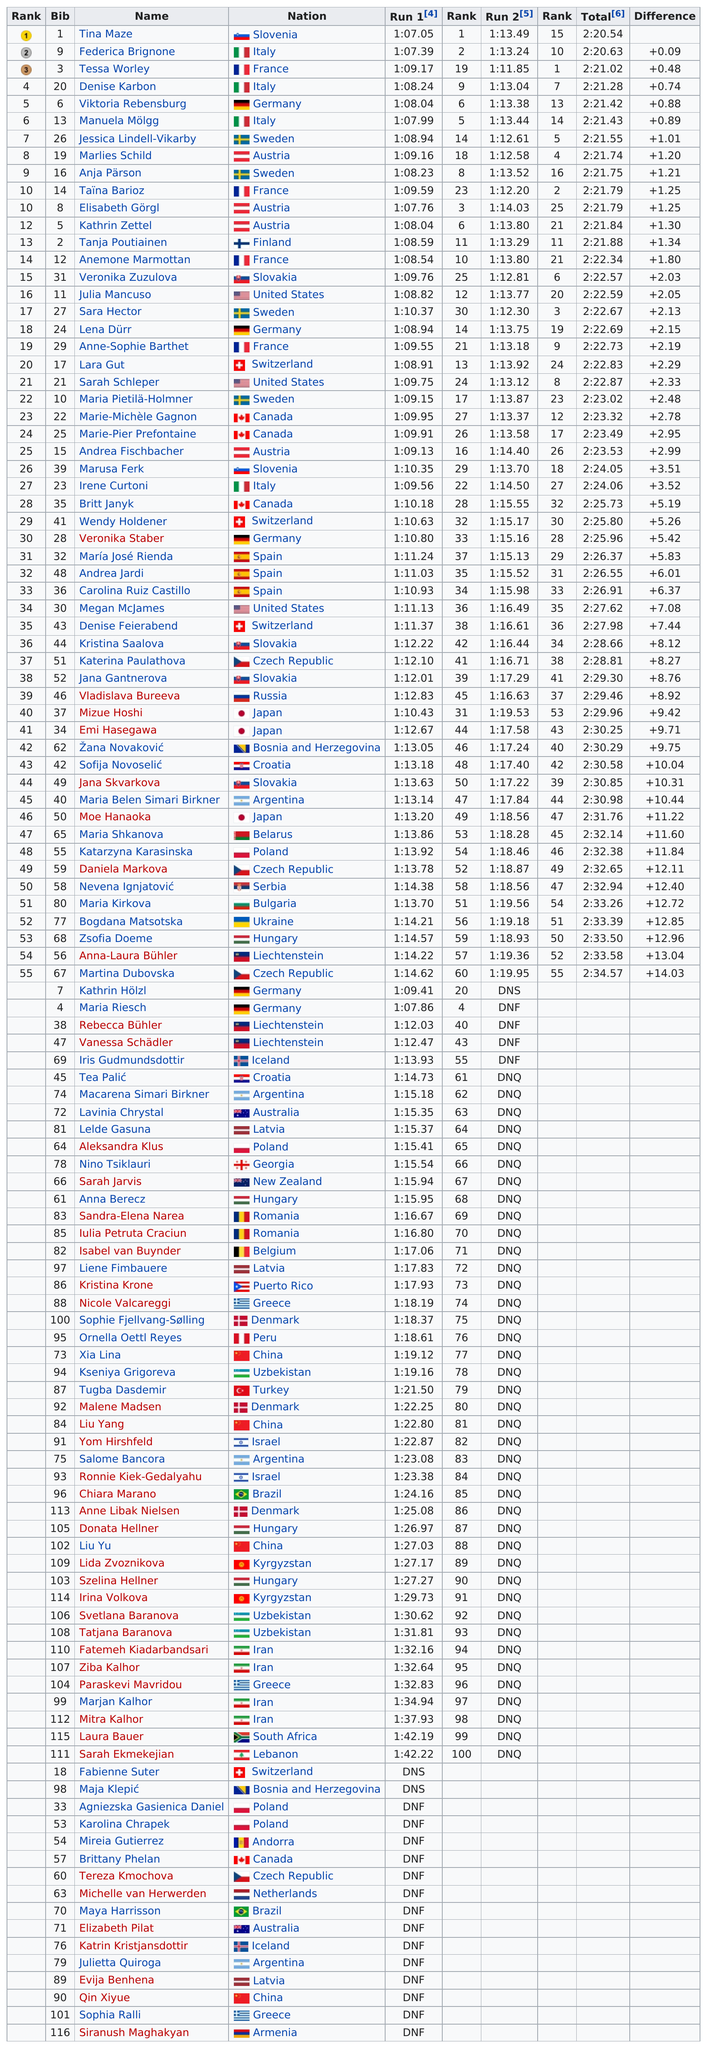Identify some key points in this picture. Tessa Worley finished next after Federica Brignone in the competition. In the latest round of the CrossFit competition, Martina Dubovska was the only competitor to successfully complete both runs, making her the last person to finish both rounds. Out of all the athletes, how many had the same rank for both run 1 and run 2? Tina completed the race in 2 hours and 20 minutes and 54 seconds. Tessa Worley ranked second after Federica Brignone in a list or order. 